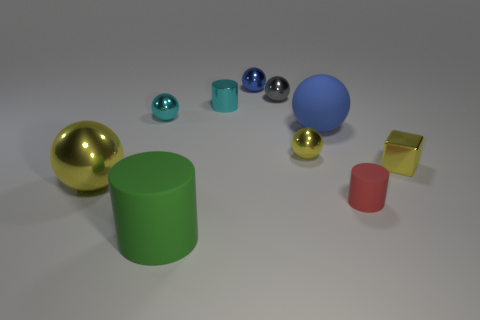Subtract all cylinders. How many objects are left? 7 Add 1 big yellow objects. How many big yellow objects are left? 2 Add 3 red matte balls. How many red matte balls exist? 3 Subtract all cyan spheres. How many spheres are left? 5 Subtract all yellow metal balls. How many balls are left? 4 Subtract 0 purple spheres. How many objects are left? 10 Subtract 1 cylinders. How many cylinders are left? 2 Subtract all green cylinders. Subtract all blue balls. How many cylinders are left? 2 Subtract all cyan cubes. How many purple spheres are left? 0 Subtract all small cyan cylinders. Subtract all small cyan metallic cylinders. How many objects are left? 8 